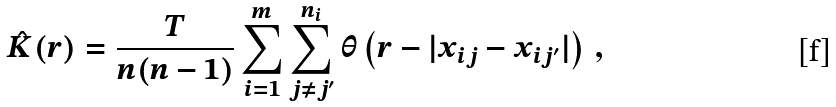<formula> <loc_0><loc_0><loc_500><loc_500>\hat { K } ( r ) = \frac { T } { n ( n - 1 ) } \sum _ { i = 1 } ^ { m } \sum _ { j \neq j ^ { \prime } } ^ { n _ { i } } \theta \left ( r - | x _ { i j } - x _ { i j ^ { \prime } } | \right ) \, ,</formula> 